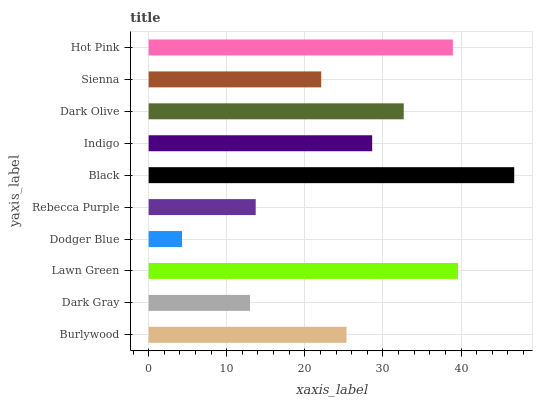Is Dodger Blue the minimum?
Answer yes or no. Yes. Is Black the maximum?
Answer yes or no. Yes. Is Dark Gray the minimum?
Answer yes or no. No. Is Dark Gray the maximum?
Answer yes or no. No. Is Burlywood greater than Dark Gray?
Answer yes or no. Yes. Is Dark Gray less than Burlywood?
Answer yes or no. Yes. Is Dark Gray greater than Burlywood?
Answer yes or no. No. Is Burlywood less than Dark Gray?
Answer yes or no. No. Is Indigo the high median?
Answer yes or no. Yes. Is Burlywood the low median?
Answer yes or no. Yes. Is Dark Gray the high median?
Answer yes or no. No. Is Dodger Blue the low median?
Answer yes or no. No. 